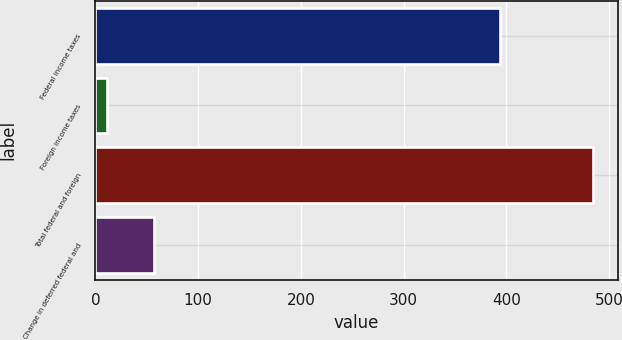Convert chart to OTSL. <chart><loc_0><loc_0><loc_500><loc_500><bar_chart><fcel>Federal income taxes<fcel>Foreign income taxes<fcel>Total federal and foreign<fcel>Change in deferred federal and<nl><fcel>394<fcel>11<fcel>484.2<fcel>57<nl></chart> 